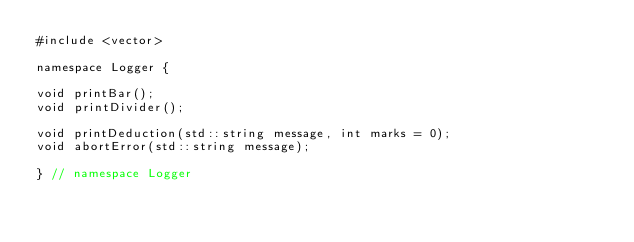<code> <loc_0><loc_0><loc_500><loc_500><_C_>#include <vector>

namespace Logger {

void printBar();
void printDivider();

void printDeduction(std::string message, int marks = 0);
void abortError(std::string message);

} // namespace Logger
</code> 